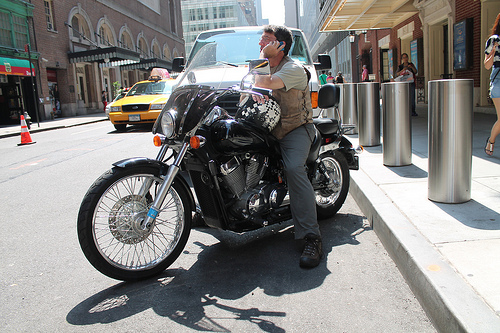Are there any people to the right of the woman on the right side? No, there are no people visible to the right of the woman; she is at the edge of the frame. 